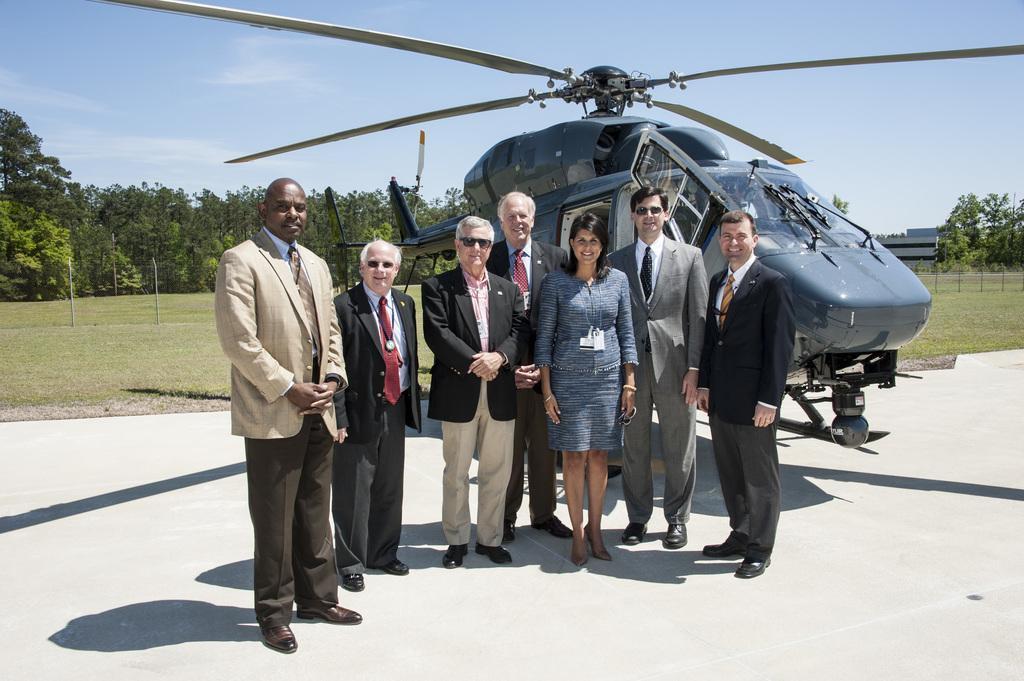In one or two sentences, can you explain what this image depicts? At the center of the image there are a few people standing, back of the there is an airplane. In the background there are trees, grass and sky. 